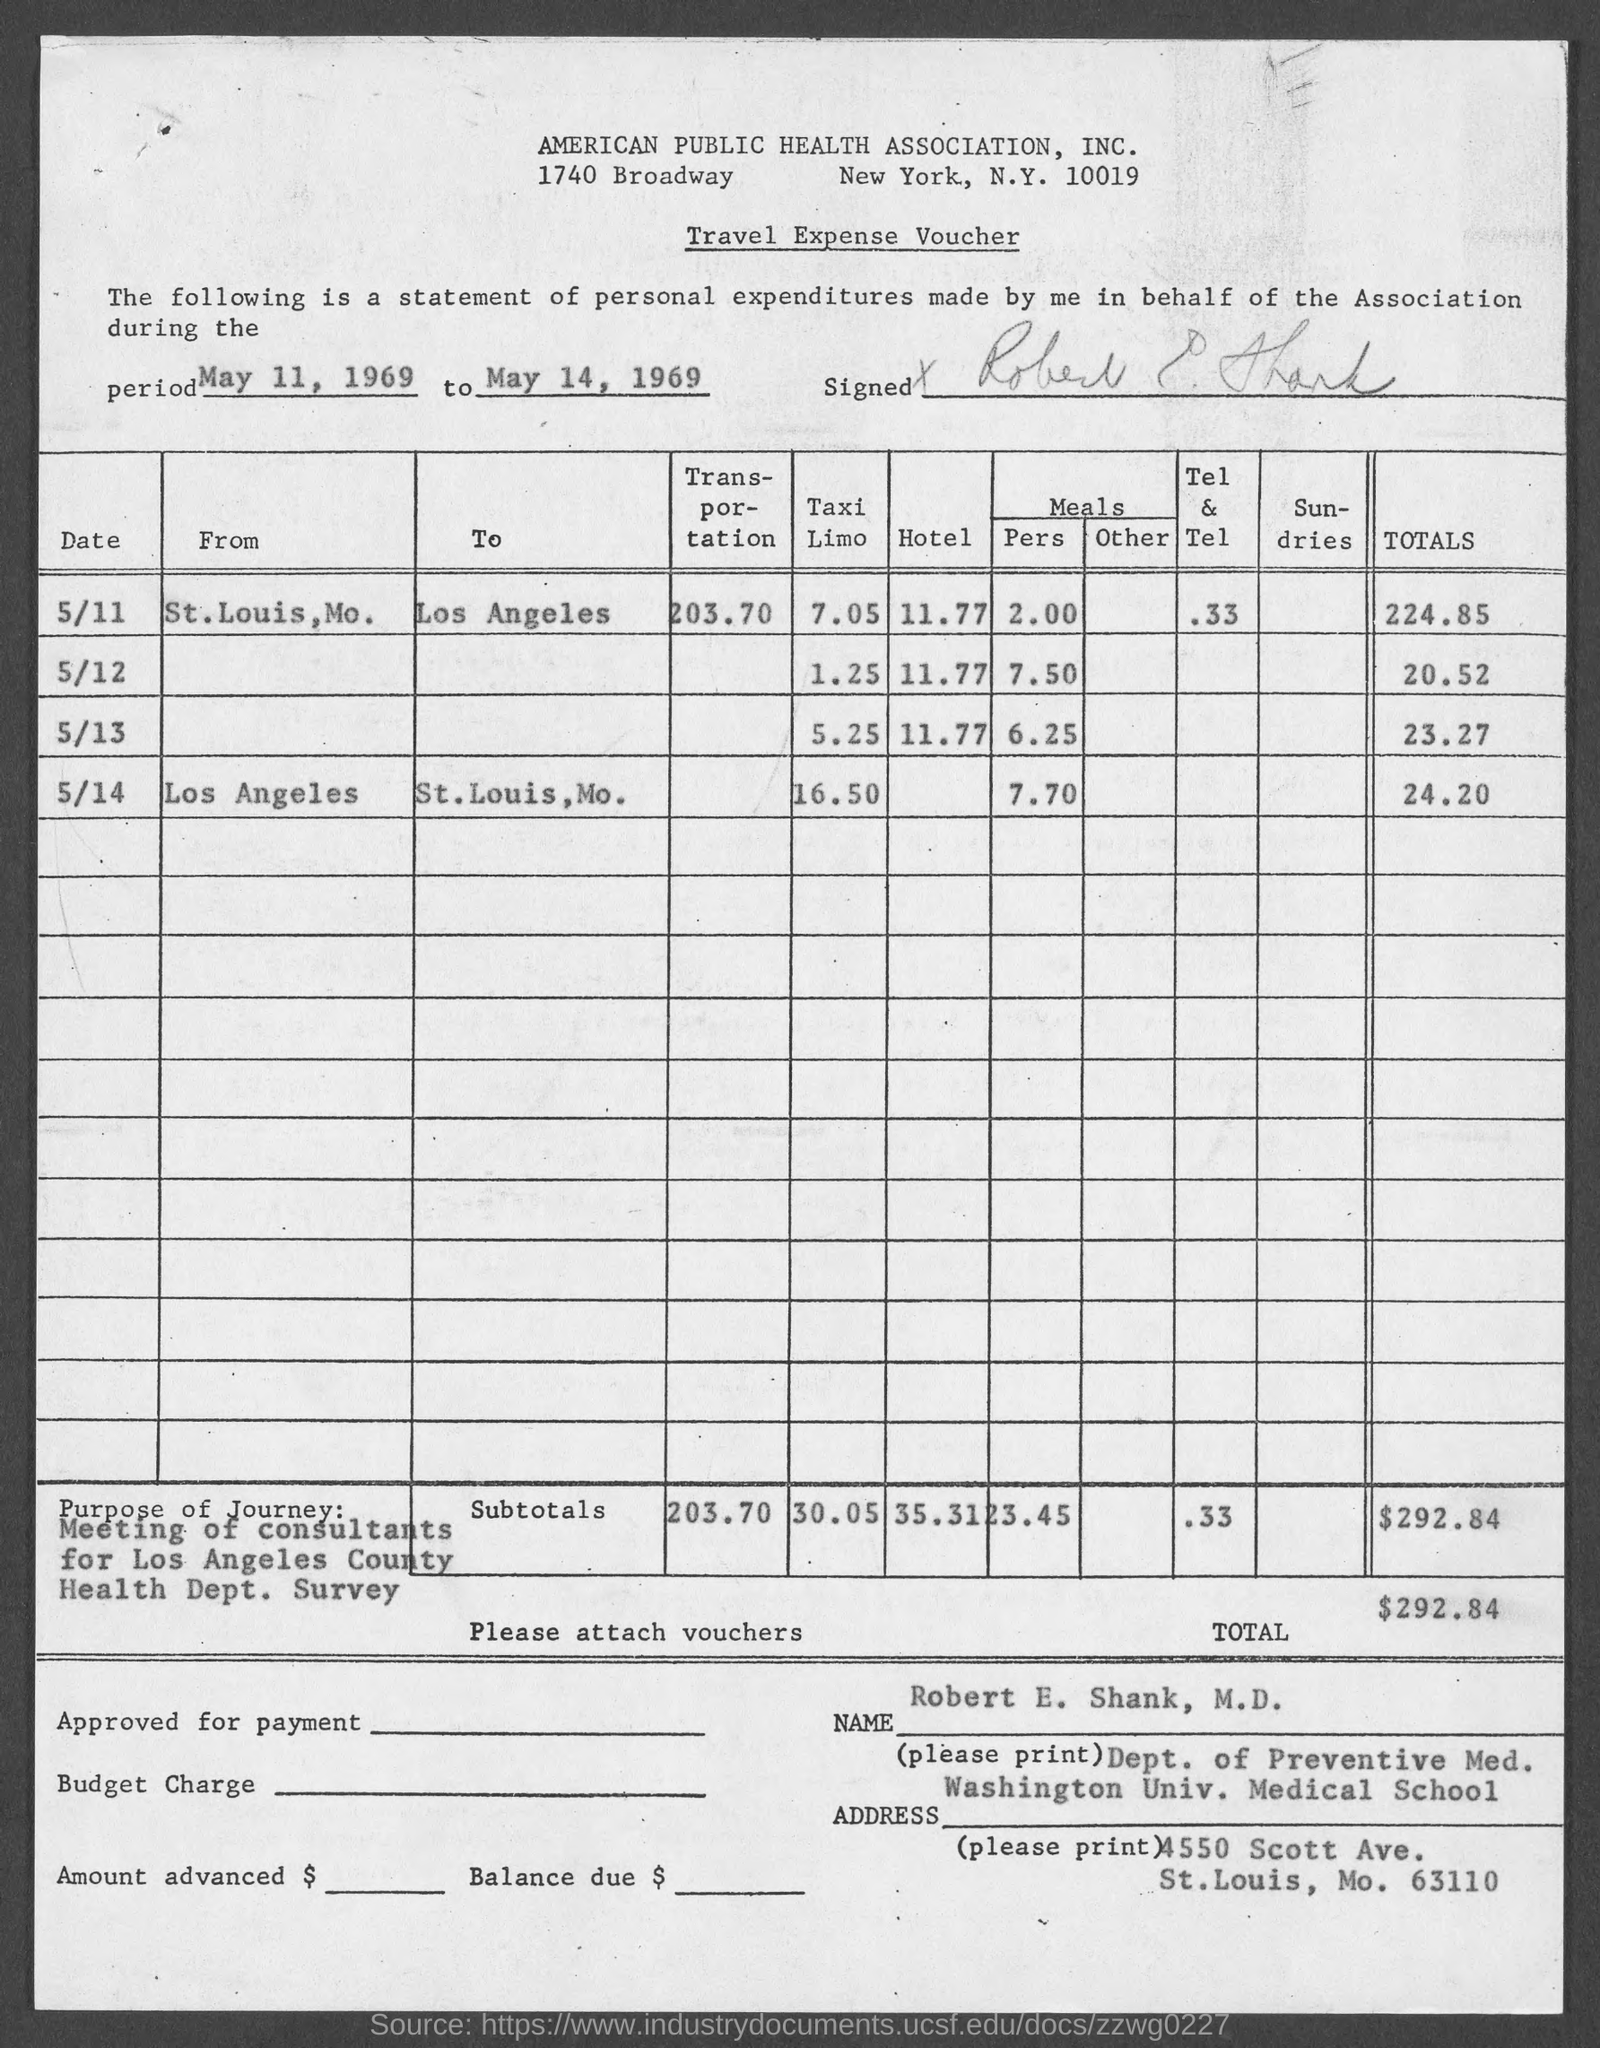What is the address of american public health association, inc.?
Your response must be concise. 1740 Broadway New York, N.Y. 10019. What is the total amount ?
Make the answer very short. 292.84. What is the period of statement of personal expenditure ?
Give a very brief answer. May 11, 1969 to May 14, 1969. 